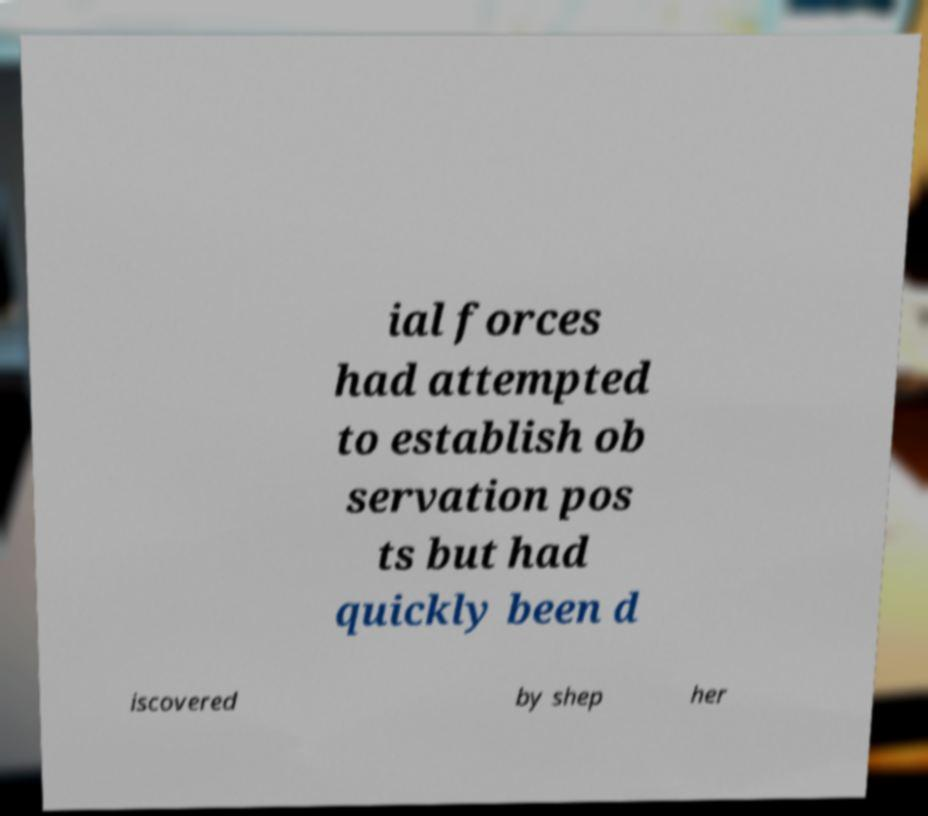What messages or text are displayed in this image? I need them in a readable, typed format. ial forces had attempted to establish ob servation pos ts but had quickly been d iscovered by shep her 